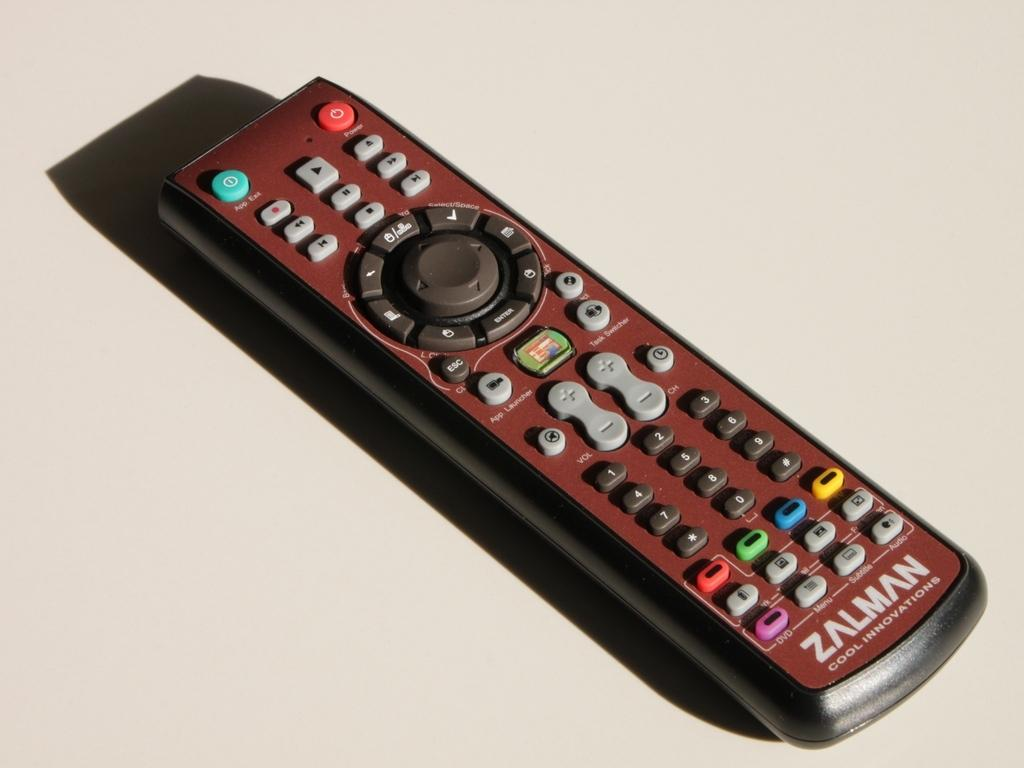Provide a one-sentence caption for the provided image. A red and black Zalman TV remote on a white surface. 